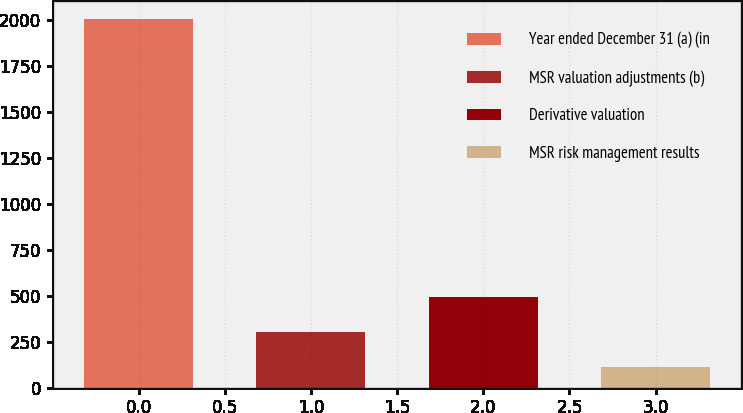<chart> <loc_0><loc_0><loc_500><loc_500><bar_chart><fcel>Year ended December 31 (a) (in<fcel>MSR valuation adjustments (b)<fcel>Derivative valuation<fcel>MSR risk management results<nl><fcel>2004<fcel>302.1<fcel>491.2<fcel>113<nl></chart> 